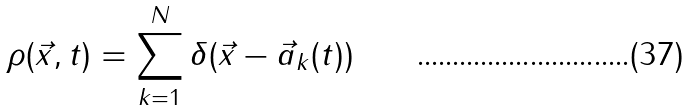Convert formula to latex. <formula><loc_0><loc_0><loc_500><loc_500>\rho ( \vec { x } , t ) = \sum _ { k = 1 } ^ { N } \delta ( \vec { x } - \vec { a } _ { k } ( t ) )</formula> 